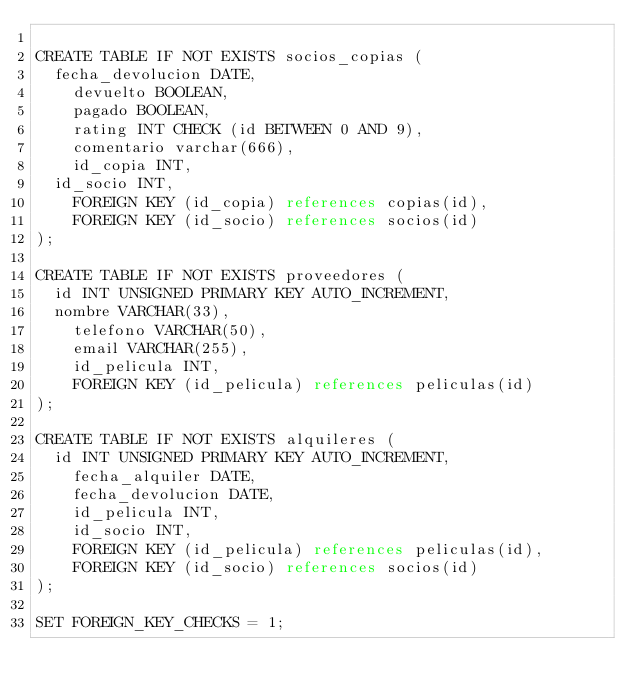Convert code to text. <code><loc_0><loc_0><loc_500><loc_500><_SQL_>
CREATE TABLE IF NOT EXISTS socios_copias (
	fecha_devolucion DATE,
    devuelto BOOLEAN,
    pagado BOOLEAN,
    rating INT CHECK (id BETWEEN 0 AND 9),
    comentario varchar(666),
    id_copia INT,
	id_socio INT,
    FOREIGN KEY (id_copia) references copias(id),
    FOREIGN KEY (id_socio) references socios(id)
);

CREATE TABLE IF NOT EXISTS proveedores (
	id INT UNSIGNED PRIMARY KEY AUTO_INCREMENT,
	nombre VARCHAR(33),
    telefono VARCHAR(50),
    email VARCHAR(255),
    id_pelicula INT,
    FOREIGN KEY (id_pelicula) references peliculas(id)
);

CREATE TABLE IF NOT EXISTS alquileres (
	id INT UNSIGNED PRIMARY KEY AUTO_INCREMENT,
    fecha_alquiler DATE,
    fecha_devolucion DATE,
    id_pelicula INT,
    id_socio INT,
    FOREIGN KEY (id_pelicula) references peliculas(id),
    FOREIGN KEY (id_socio) references socios(id)
);

SET FOREIGN_KEY_CHECKS = 1;
    </code> 